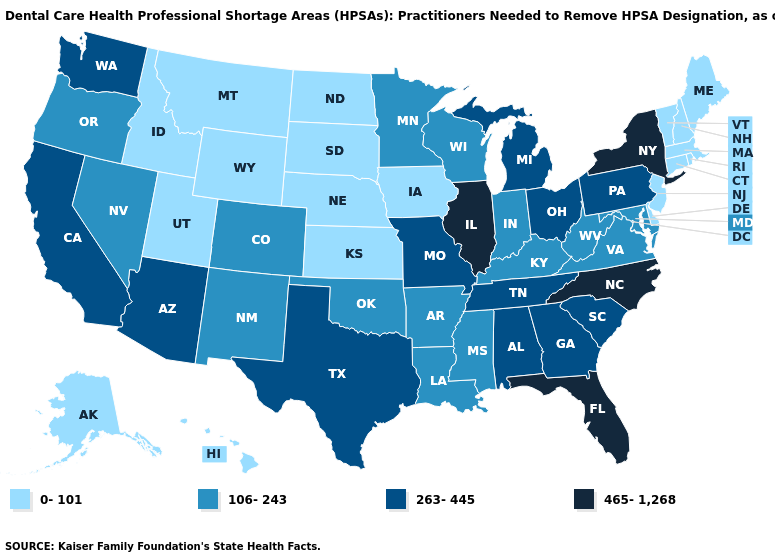Name the states that have a value in the range 106-243?
Short answer required. Arkansas, Colorado, Indiana, Kentucky, Louisiana, Maryland, Minnesota, Mississippi, Nevada, New Mexico, Oklahoma, Oregon, Virginia, West Virginia, Wisconsin. What is the value of Virginia?
Be succinct. 106-243. Does Louisiana have a lower value than North Carolina?
Answer briefly. Yes. Among the states that border Delaware , which have the highest value?
Short answer required. Pennsylvania. Does Idaho have the same value as Nebraska?
Concise answer only. Yes. What is the highest value in the MidWest ?
Keep it brief. 465-1,268. What is the value of Kansas?
Concise answer only. 0-101. Name the states that have a value in the range 465-1,268?
Concise answer only. Florida, Illinois, New York, North Carolina. What is the highest value in the USA?
Quick response, please. 465-1,268. Name the states that have a value in the range 0-101?
Keep it brief. Alaska, Connecticut, Delaware, Hawaii, Idaho, Iowa, Kansas, Maine, Massachusetts, Montana, Nebraska, New Hampshire, New Jersey, North Dakota, Rhode Island, South Dakota, Utah, Vermont, Wyoming. Name the states that have a value in the range 465-1,268?
Short answer required. Florida, Illinois, New York, North Carolina. Is the legend a continuous bar?
Give a very brief answer. No. Does the first symbol in the legend represent the smallest category?
Be succinct. Yes. Does Illinois have the highest value in the MidWest?
Quick response, please. Yes. 